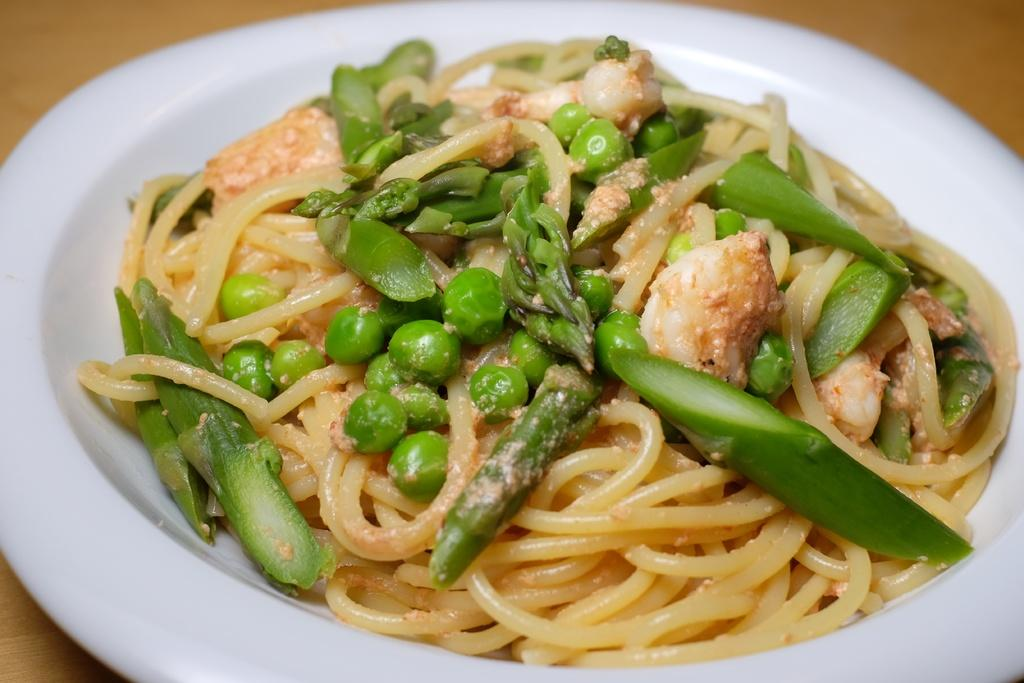What is present on the plate in the image? The plate contains food items. Where is the plate located in the image? The plate is placed on a platform. What type of wall can be seen in the image? There is no wall present in the image. 